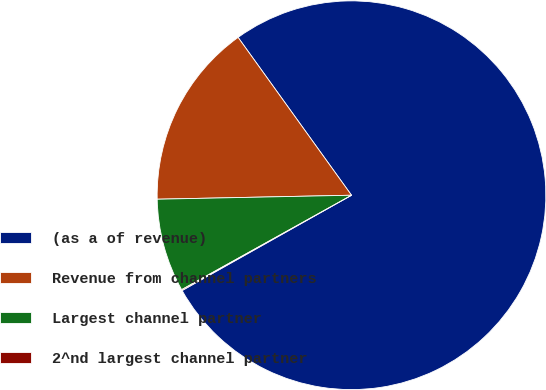Convert chart to OTSL. <chart><loc_0><loc_0><loc_500><loc_500><pie_chart><fcel>(as a of revenue)<fcel>Revenue from channel partners<fcel>Largest channel partner<fcel>2^nd largest channel partner<nl><fcel>76.76%<fcel>15.41%<fcel>7.75%<fcel>0.08%<nl></chart> 